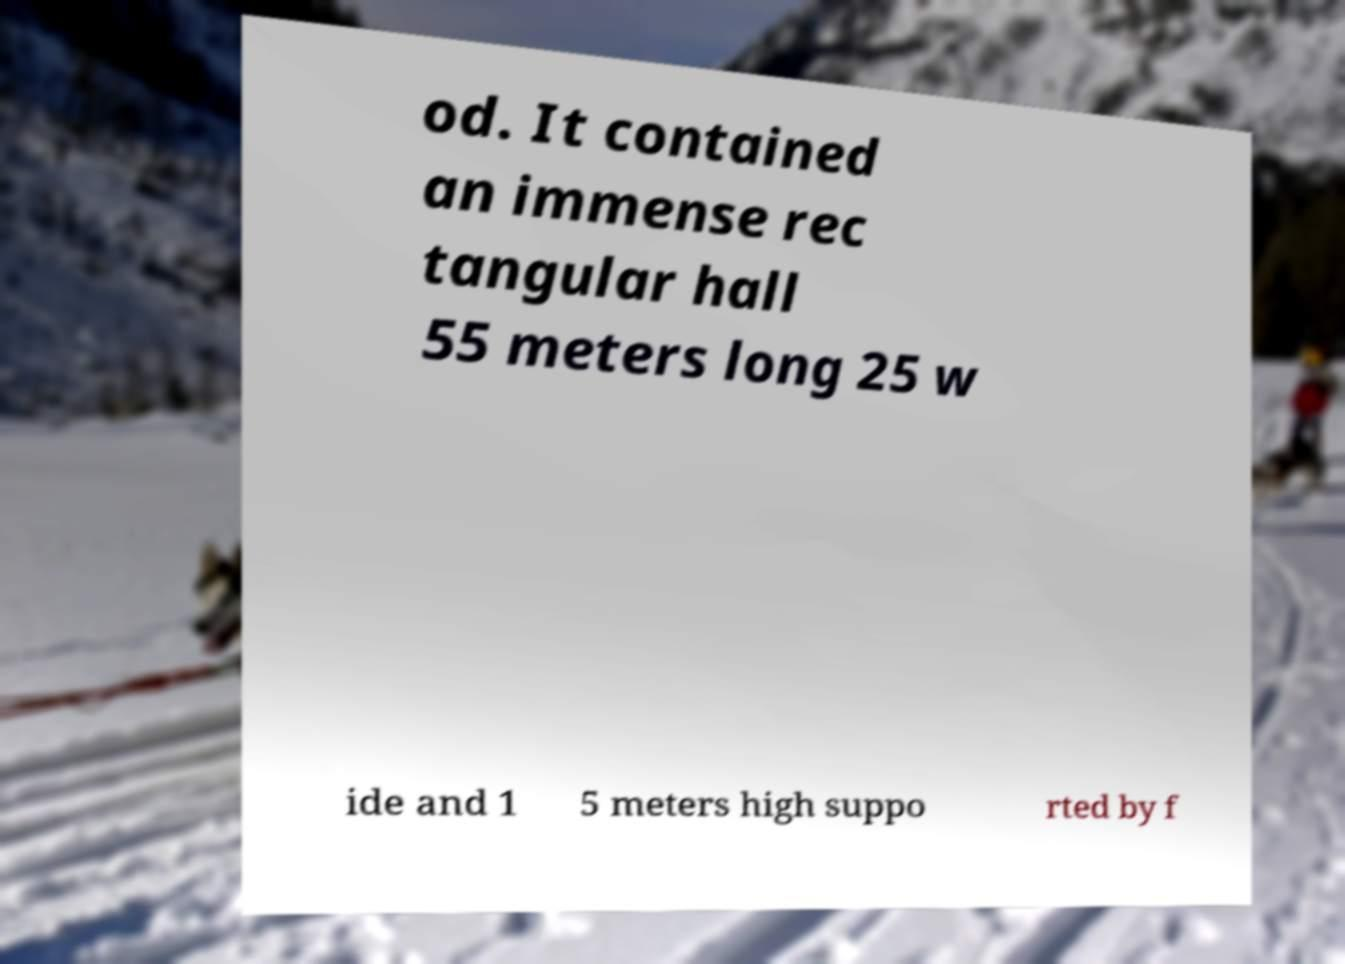Could you assist in decoding the text presented in this image and type it out clearly? od. It contained an immense rec tangular hall 55 meters long 25 w ide and 1 5 meters high suppo rted by f 